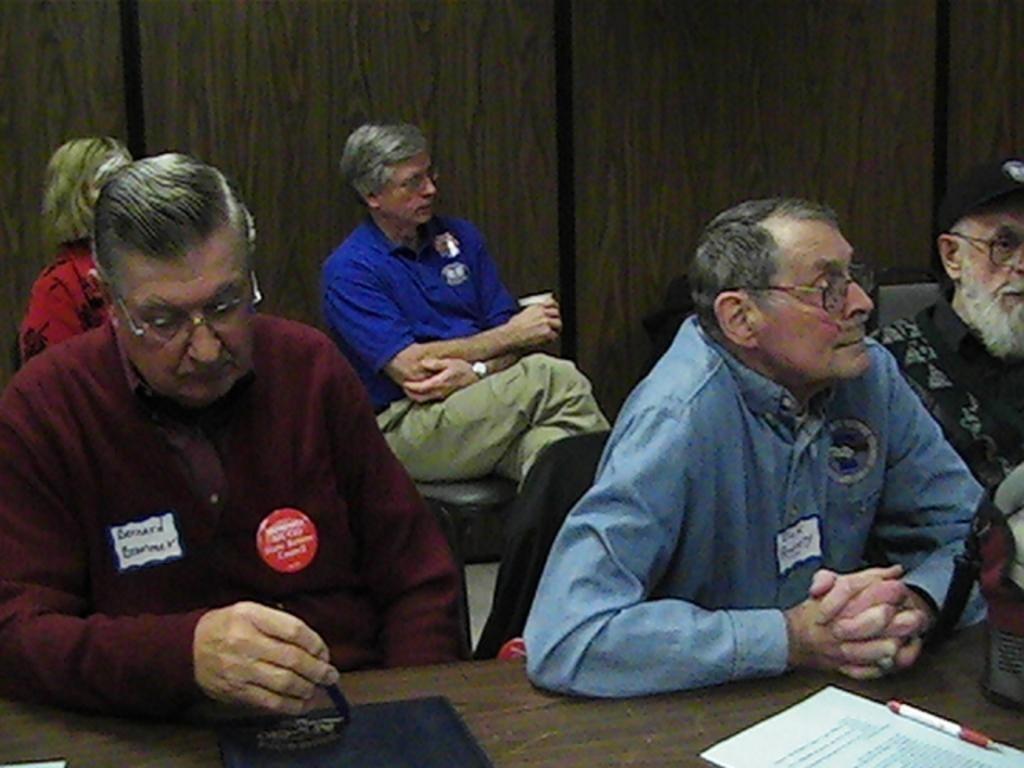What is located in the bottom right corner of the image? There is a paper in the bottom right corner of the image. What object is on the table in the image? There is a pen on the table in the image. What can be seen in the middle of the image? There are people sitting in the middle of the image. What are the people wearing that indicates their affiliation or role? The people are wearing badges. What type of shirt is the cushion wearing in the image? There is no cushion present in the image, and cushions do not wear shirts. 